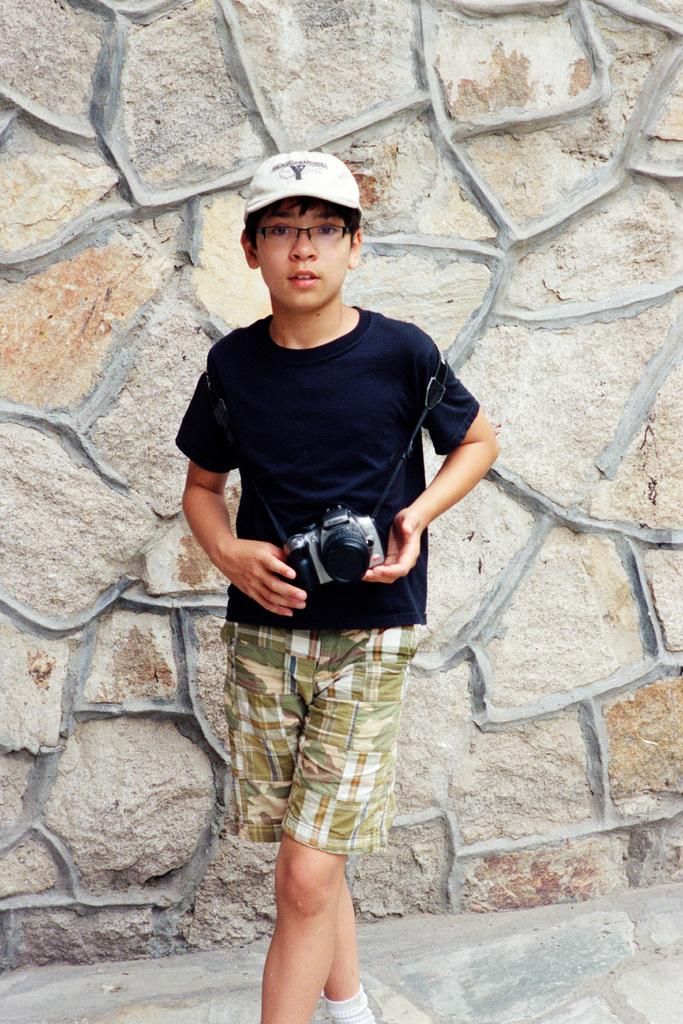What is the person in the image doing? The person in the image is holding a camera in their hands. What is the person wearing? The person is wearing a black t-shirt and green-colored shorts. What can be seen in the background of the image? There are stones visible in the background of the image. What type of birthday celebration is happening in the image? There is no indication of a birthday celebration in the image. How many sticks can be seen in the person's hand in the image? The person is not holding any sticks in the image; they are holding a camera. 